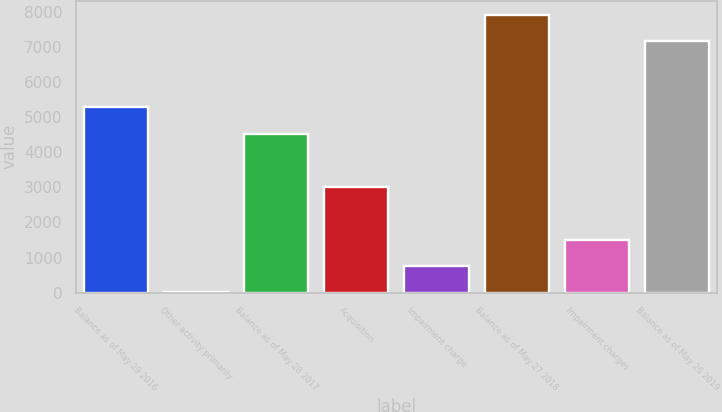Convert chart to OTSL. <chart><loc_0><loc_0><loc_500><loc_500><bar_chart><fcel>Balance as of May 29 2016<fcel>Other activity primarily<fcel>Balance as of May 28 2017<fcel>Acquisition<fcel>Impairment charge<fcel>Balance as of May 27 2018<fcel>Impairment charges<fcel>Balance as of May 26 2019<nl><fcel>5274.09<fcel>8.2<fcel>4530.4<fcel>3015<fcel>751.89<fcel>7910.49<fcel>1495.58<fcel>7166.8<nl></chart> 